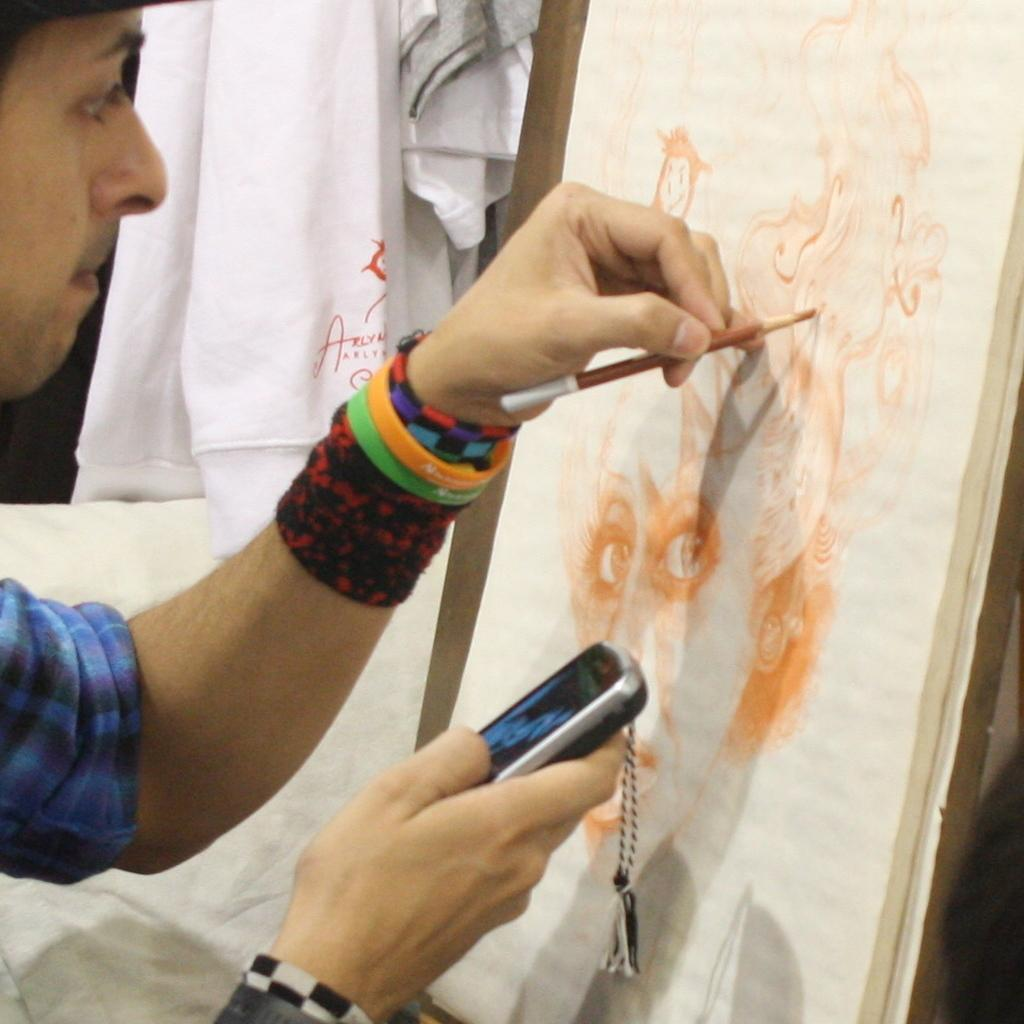What is the person in the image doing? The person is painting on a paper. What object does the person have in his hand? The person has a mobile in his hand. What can be seen on the table or surface in the image? There is a pencil and a board in the image. What type of material is visible in the image? There are clothes in the image. What type of reaction can be seen in the vessel in the image? There is no vessel present in the image, and therefore no reaction can be observed. 